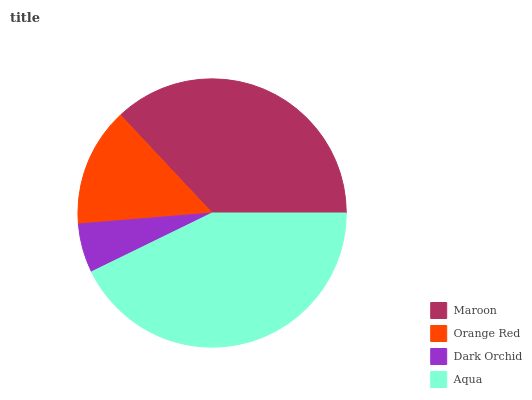Is Dark Orchid the minimum?
Answer yes or no. Yes. Is Aqua the maximum?
Answer yes or no. Yes. Is Orange Red the minimum?
Answer yes or no. No. Is Orange Red the maximum?
Answer yes or no. No. Is Maroon greater than Orange Red?
Answer yes or no. Yes. Is Orange Red less than Maroon?
Answer yes or no. Yes. Is Orange Red greater than Maroon?
Answer yes or no. No. Is Maroon less than Orange Red?
Answer yes or no. No. Is Maroon the high median?
Answer yes or no. Yes. Is Orange Red the low median?
Answer yes or no. Yes. Is Orange Red the high median?
Answer yes or no. No. Is Aqua the low median?
Answer yes or no. No. 